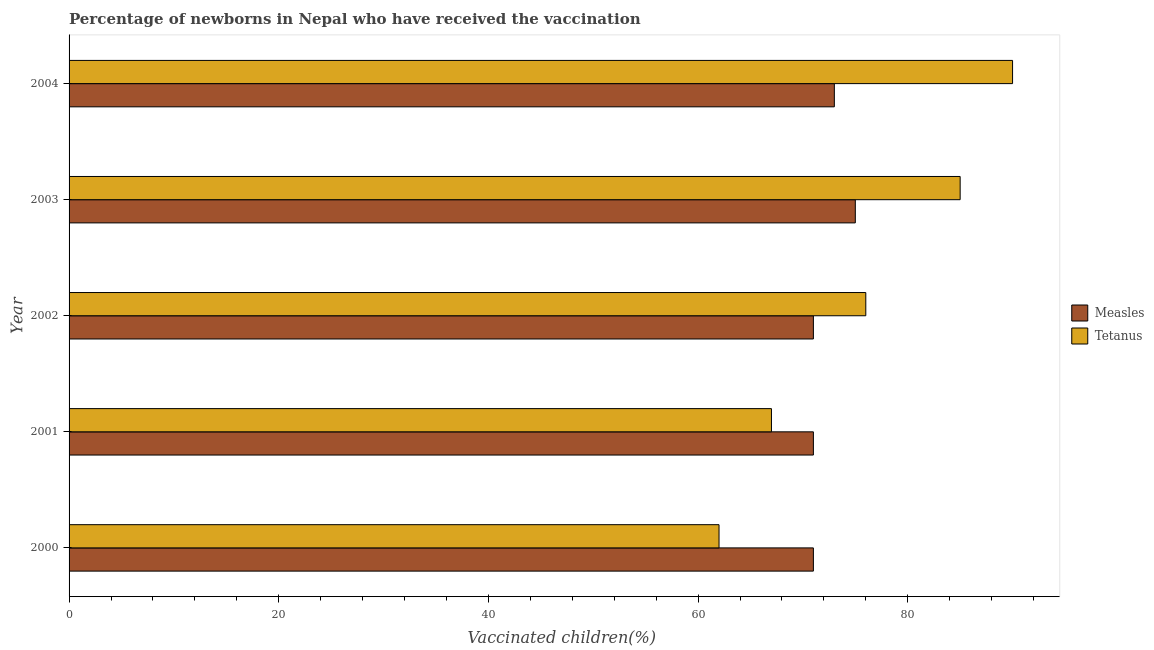How many groups of bars are there?
Offer a terse response. 5. Are the number of bars per tick equal to the number of legend labels?
Give a very brief answer. Yes. Are the number of bars on each tick of the Y-axis equal?
Offer a very short reply. Yes. What is the percentage of newborns who received vaccination for tetanus in 2000?
Offer a terse response. 62. Across all years, what is the maximum percentage of newborns who received vaccination for tetanus?
Offer a terse response. 90. Across all years, what is the minimum percentage of newborns who received vaccination for measles?
Keep it short and to the point. 71. What is the total percentage of newborns who received vaccination for measles in the graph?
Make the answer very short. 361. What is the difference between the percentage of newborns who received vaccination for tetanus in 2001 and that in 2003?
Make the answer very short. -18. What is the difference between the percentage of newborns who received vaccination for measles in 2000 and the percentage of newborns who received vaccination for tetanus in 2003?
Ensure brevity in your answer.  -14. What is the average percentage of newborns who received vaccination for measles per year?
Your answer should be very brief. 72.2. In the year 2002, what is the difference between the percentage of newborns who received vaccination for measles and percentage of newborns who received vaccination for tetanus?
Keep it short and to the point. -5. What is the ratio of the percentage of newborns who received vaccination for tetanus in 2000 to that in 2003?
Your answer should be compact. 0.73. Is the percentage of newborns who received vaccination for measles in 2000 less than that in 2003?
Provide a short and direct response. Yes. What is the difference between the highest and the lowest percentage of newborns who received vaccination for tetanus?
Your answer should be compact. 28. What does the 2nd bar from the top in 2003 represents?
Provide a succinct answer. Measles. What does the 1st bar from the bottom in 2004 represents?
Your answer should be compact. Measles. How many bars are there?
Keep it short and to the point. 10. Are all the bars in the graph horizontal?
Offer a terse response. Yes. What is the difference between two consecutive major ticks on the X-axis?
Offer a terse response. 20. Are the values on the major ticks of X-axis written in scientific E-notation?
Provide a succinct answer. No. Does the graph contain grids?
Ensure brevity in your answer.  No. Where does the legend appear in the graph?
Offer a very short reply. Center right. What is the title of the graph?
Make the answer very short. Percentage of newborns in Nepal who have received the vaccination. Does "Foreign liabilities" appear as one of the legend labels in the graph?
Give a very brief answer. No. What is the label or title of the X-axis?
Your answer should be very brief. Vaccinated children(%)
. What is the label or title of the Y-axis?
Provide a succinct answer. Year. What is the Vaccinated children(%)
 in Measles in 2001?
Give a very brief answer. 71. What is the Vaccinated children(%)
 of Measles in 2002?
Your answer should be compact. 71. What is the Vaccinated children(%)
 in Tetanus in 2002?
Provide a succinct answer. 76. What is the Vaccinated children(%)
 in Measles in 2003?
Make the answer very short. 75. What is the Vaccinated children(%)
 in Tetanus in 2003?
Your answer should be very brief. 85. What is the Vaccinated children(%)
 of Measles in 2004?
Your answer should be very brief. 73. Across all years, what is the maximum Vaccinated children(%)
 in Measles?
Your response must be concise. 75. Across all years, what is the minimum Vaccinated children(%)
 in Tetanus?
Offer a very short reply. 62. What is the total Vaccinated children(%)
 of Measles in the graph?
Your response must be concise. 361. What is the total Vaccinated children(%)
 in Tetanus in the graph?
Ensure brevity in your answer.  380. What is the difference between the Vaccinated children(%)
 in Measles in 2000 and that in 2001?
Make the answer very short. 0. What is the difference between the Vaccinated children(%)
 in Tetanus in 2000 and that in 2004?
Keep it short and to the point. -28. What is the difference between the Vaccinated children(%)
 of Measles in 2001 and that in 2002?
Offer a terse response. 0. What is the difference between the Vaccinated children(%)
 in Tetanus in 2002 and that in 2003?
Offer a terse response. -9. What is the difference between the Vaccinated children(%)
 in Measles in 2002 and that in 2004?
Your answer should be compact. -2. What is the difference between the Vaccinated children(%)
 of Tetanus in 2002 and that in 2004?
Your answer should be very brief. -14. What is the difference between the Vaccinated children(%)
 of Tetanus in 2003 and that in 2004?
Keep it short and to the point. -5. What is the difference between the Vaccinated children(%)
 in Measles in 2000 and the Vaccinated children(%)
 in Tetanus in 2002?
Keep it short and to the point. -5. What is the difference between the Vaccinated children(%)
 in Measles in 2000 and the Vaccinated children(%)
 in Tetanus in 2003?
Make the answer very short. -14. What is the difference between the Vaccinated children(%)
 in Measles in 2000 and the Vaccinated children(%)
 in Tetanus in 2004?
Keep it short and to the point. -19. What is the difference between the Vaccinated children(%)
 of Measles in 2001 and the Vaccinated children(%)
 of Tetanus in 2004?
Your answer should be very brief. -19. What is the difference between the Vaccinated children(%)
 of Measles in 2002 and the Vaccinated children(%)
 of Tetanus in 2004?
Make the answer very short. -19. What is the difference between the Vaccinated children(%)
 in Measles in 2003 and the Vaccinated children(%)
 in Tetanus in 2004?
Provide a short and direct response. -15. What is the average Vaccinated children(%)
 in Measles per year?
Your answer should be very brief. 72.2. In the year 2000, what is the difference between the Vaccinated children(%)
 in Measles and Vaccinated children(%)
 in Tetanus?
Ensure brevity in your answer.  9. In the year 2001, what is the difference between the Vaccinated children(%)
 in Measles and Vaccinated children(%)
 in Tetanus?
Make the answer very short. 4. In the year 2002, what is the difference between the Vaccinated children(%)
 in Measles and Vaccinated children(%)
 in Tetanus?
Your answer should be very brief. -5. In the year 2004, what is the difference between the Vaccinated children(%)
 in Measles and Vaccinated children(%)
 in Tetanus?
Keep it short and to the point. -17. What is the ratio of the Vaccinated children(%)
 in Measles in 2000 to that in 2001?
Provide a short and direct response. 1. What is the ratio of the Vaccinated children(%)
 of Tetanus in 2000 to that in 2001?
Keep it short and to the point. 0.93. What is the ratio of the Vaccinated children(%)
 of Measles in 2000 to that in 2002?
Provide a short and direct response. 1. What is the ratio of the Vaccinated children(%)
 in Tetanus in 2000 to that in 2002?
Offer a terse response. 0.82. What is the ratio of the Vaccinated children(%)
 of Measles in 2000 to that in 2003?
Provide a succinct answer. 0.95. What is the ratio of the Vaccinated children(%)
 of Tetanus in 2000 to that in 2003?
Your answer should be very brief. 0.73. What is the ratio of the Vaccinated children(%)
 in Measles in 2000 to that in 2004?
Give a very brief answer. 0.97. What is the ratio of the Vaccinated children(%)
 of Tetanus in 2000 to that in 2004?
Make the answer very short. 0.69. What is the ratio of the Vaccinated children(%)
 of Tetanus in 2001 to that in 2002?
Offer a very short reply. 0.88. What is the ratio of the Vaccinated children(%)
 in Measles in 2001 to that in 2003?
Your answer should be very brief. 0.95. What is the ratio of the Vaccinated children(%)
 in Tetanus in 2001 to that in 2003?
Offer a terse response. 0.79. What is the ratio of the Vaccinated children(%)
 of Measles in 2001 to that in 2004?
Offer a terse response. 0.97. What is the ratio of the Vaccinated children(%)
 of Tetanus in 2001 to that in 2004?
Provide a short and direct response. 0.74. What is the ratio of the Vaccinated children(%)
 in Measles in 2002 to that in 2003?
Make the answer very short. 0.95. What is the ratio of the Vaccinated children(%)
 in Tetanus in 2002 to that in 2003?
Offer a terse response. 0.89. What is the ratio of the Vaccinated children(%)
 of Measles in 2002 to that in 2004?
Ensure brevity in your answer.  0.97. What is the ratio of the Vaccinated children(%)
 in Tetanus in 2002 to that in 2004?
Keep it short and to the point. 0.84. What is the ratio of the Vaccinated children(%)
 in Measles in 2003 to that in 2004?
Provide a short and direct response. 1.03. What is the ratio of the Vaccinated children(%)
 of Tetanus in 2003 to that in 2004?
Give a very brief answer. 0.94. What is the difference between the highest and the second highest Vaccinated children(%)
 of Measles?
Offer a terse response. 2. What is the difference between the highest and the second highest Vaccinated children(%)
 of Tetanus?
Provide a short and direct response. 5. What is the difference between the highest and the lowest Vaccinated children(%)
 of Tetanus?
Offer a very short reply. 28. 